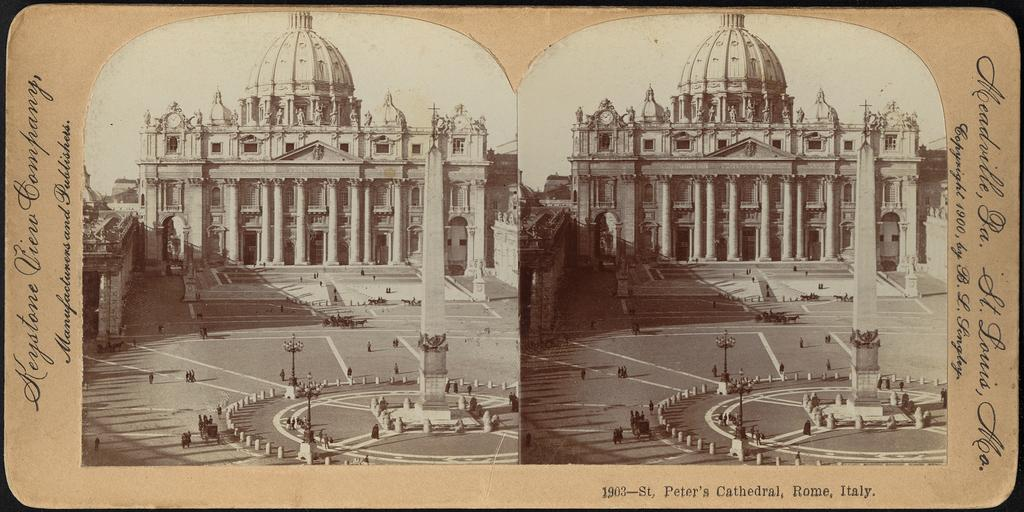<image>
Create a compact narrative representing the image presented. An old photo with 1903-St. Peter's Cathedral, Rome, Italy written on the bottom right. 